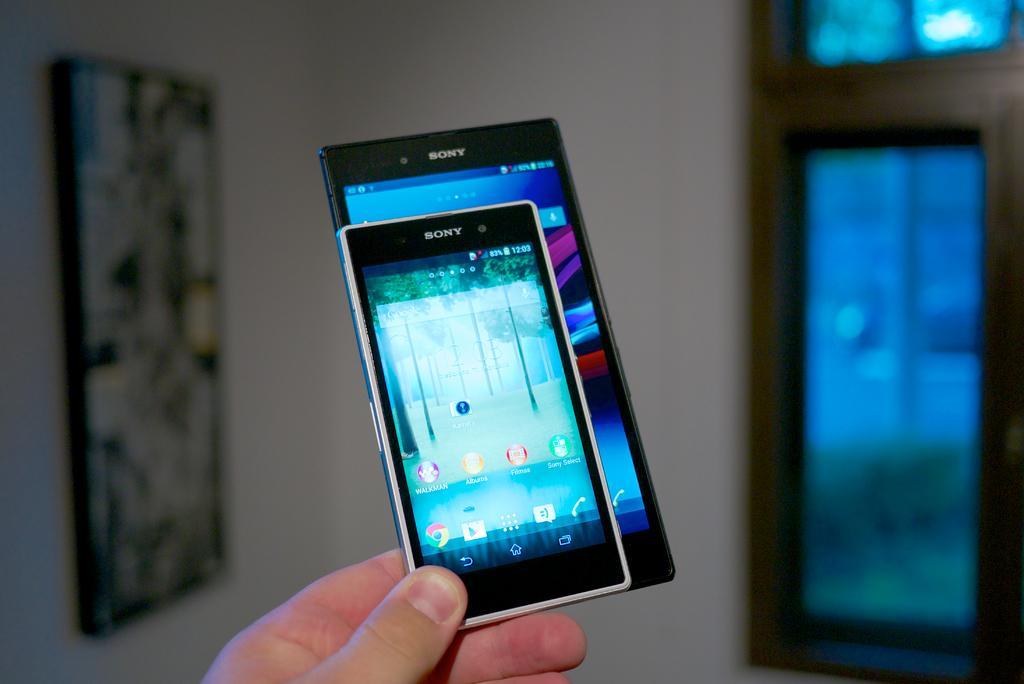<image>
Create a compact narrative representing the image presented. A comparison in size of two Sony smartphones being held in the fingertips of a person. 